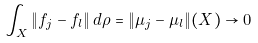<formula> <loc_0><loc_0><loc_500><loc_500>\int _ { X } \| f _ { j } - f _ { l } \| \, d \rho = \| \mu _ { j } - \mu _ { l } \| ( X ) \to 0</formula> 